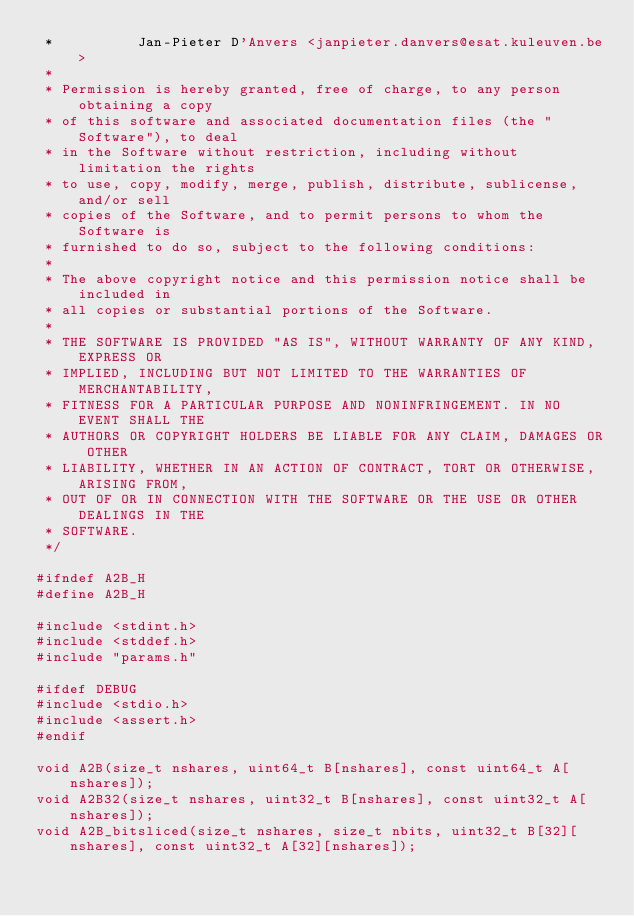Convert code to text. <code><loc_0><loc_0><loc_500><loc_500><_C_> *          Jan-Pieter D'Anvers <janpieter.danvers@esat.kuleuven.be>
 *
 * Permission is hereby granted, free of charge, to any person obtaining a copy
 * of this software and associated documentation files (the "Software"), to deal
 * in the Software without restriction, including without limitation the rights
 * to use, copy, modify, merge, publish, distribute, sublicense, and/or sell
 * copies of the Software, and to permit persons to whom the Software is
 * furnished to do so, subject to the following conditions:
 *
 * The above copyright notice and this permission notice shall be included in
 * all copies or substantial portions of the Software.
 *
 * THE SOFTWARE IS PROVIDED "AS IS", WITHOUT WARRANTY OF ANY KIND, EXPRESS OR
 * IMPLIED, INCLUDING BUT NOT LIMITED TO THE WARRANTIES OF MERCHANTABILITY,
 * FITNESS FOR A PARTICULAR PURPOSE AND NONINFRINGEMENT. IN NO EVENT SHALL THE
 * AUTHORS OR COPYRIGHT HOLDERS BE LIABLE FOR ANY CLAIM, DAMAGES OR OTHER
 * LIABILITY, WHETHER IN AN ACTION OF CONTRACT, TORT OR OTHERWISE, ARISING FROM,
 * OUT OF OR IN CONNECTION WITH THE SOFTWARE OR THE USE OR OTHER DEALINGS IN THE
 * SOFTWARE.
 */

#ifndef A2B_H
#define A2B_H

#include <stdint.h>
#include <stddef.h>
#include "params.h"

#ifdef DEBUG
#include <stdio.h>
#include <assert.h>
#endif

void A2B(size_t nshares, uint64_t B[nshares], const uint64_t A[nshares]);
void A2B32(size_t nshares, uint32_t B[nshares], const uint32_t A[nshares]);
void A2B_bitsliced(size_t nshares, size_t nbits, uint32_t B[32][nshares], const uint32_t A[32][nshares]);</code> 